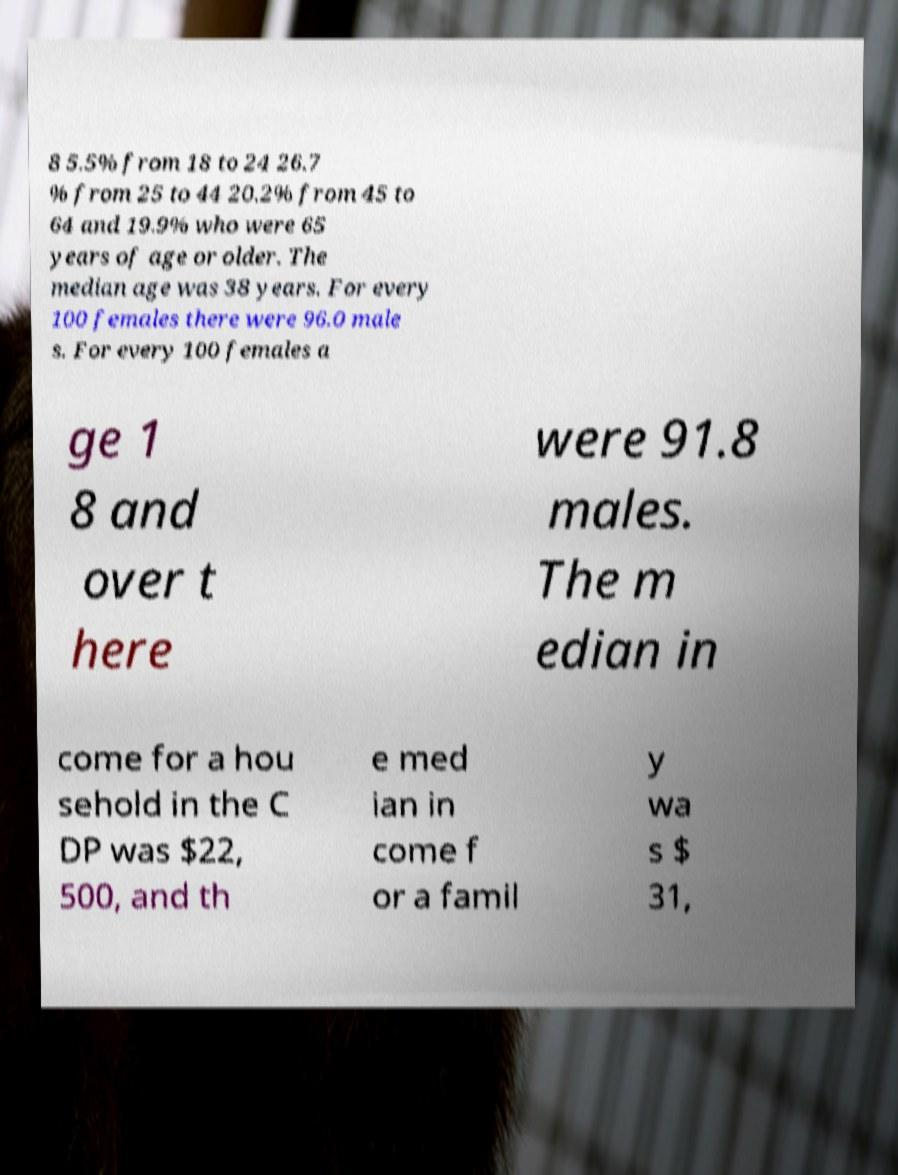There's text embedded in this image that I need extracted. Can you transcribe it verbatim? 8 5.5% from 18 to 24 26.7 % from 25 to 44 20.2% from 45 to 64 and 19.9% who were 65 years of age or older. The median age was 38 years. For every 100 females there were 96.0 male s. For every 100 females a ge 1 8 and over t here were 91.8 males. The m edian in come for a hou sehold in the C DP was $22, 500, and th e med ian in come f or a famil y wa s $ 31, 